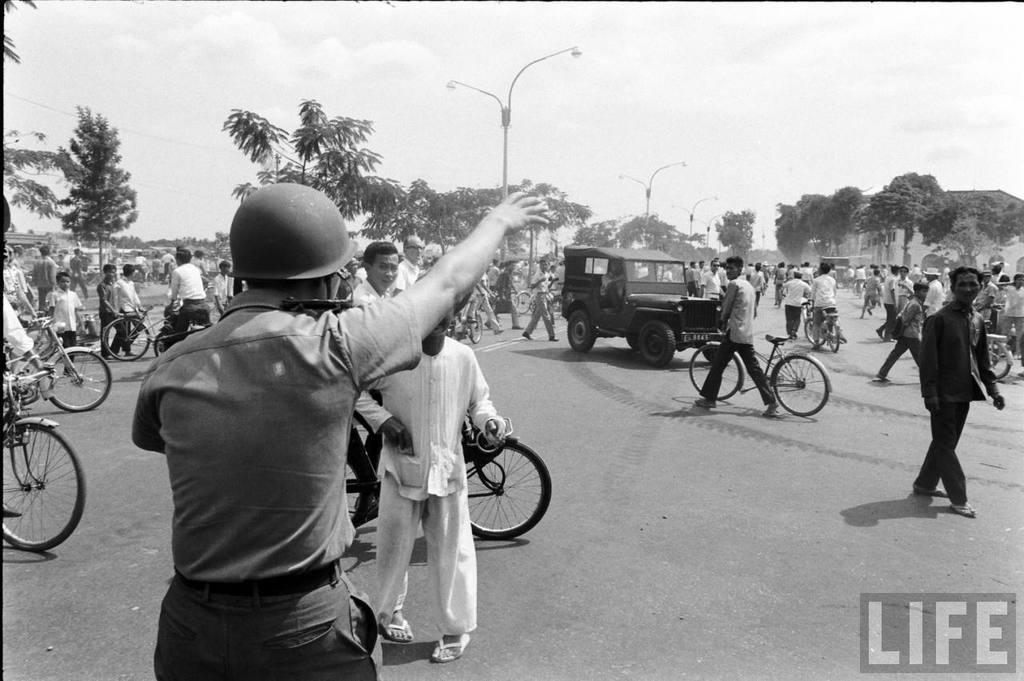Can you describe this image briefly? This is a black and white picture. here we can see all the persons riding bicycles on the road and there are vehicles. These are street lights. At the top there is a sky. 